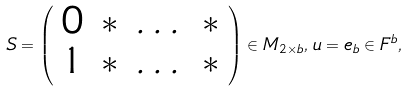<formula> <loc_0><loc_0><loc_500><loc_500>S = \left ( \begin{array} { c c c c } 0 & * & \dots & * \\ 1 & * & \dots & * \\ \end{array} \right ) \in M _ { 2 \times b } , \, u = e _ { b } \in F ^ { b } ,</formula> 